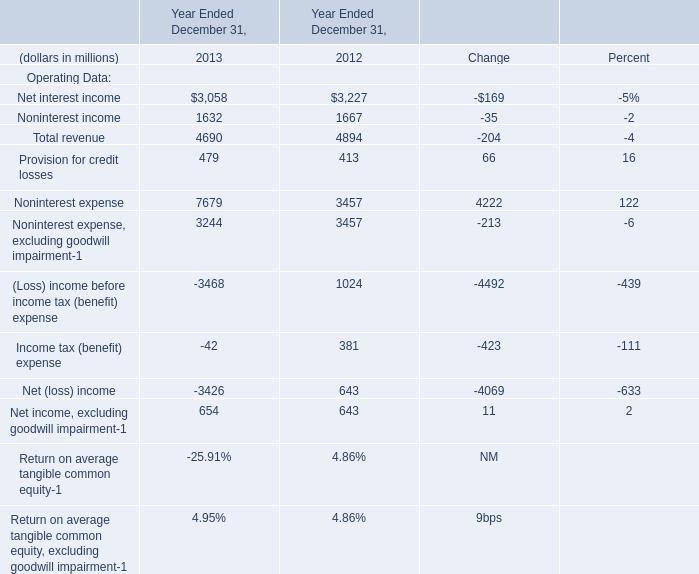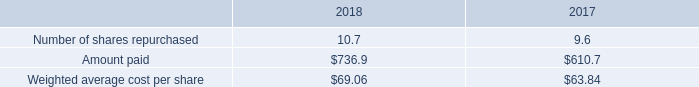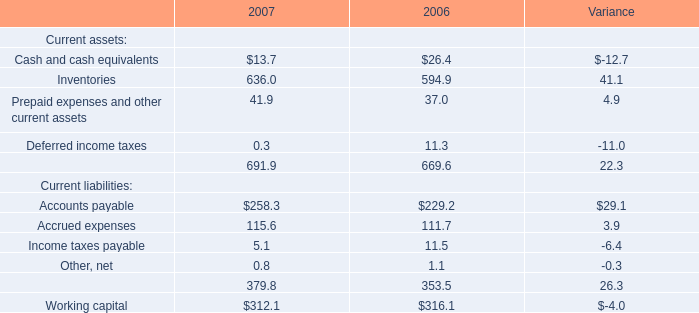Does the value of Net interest income in 2013 greater than that in 2012? 
Answer: no. 